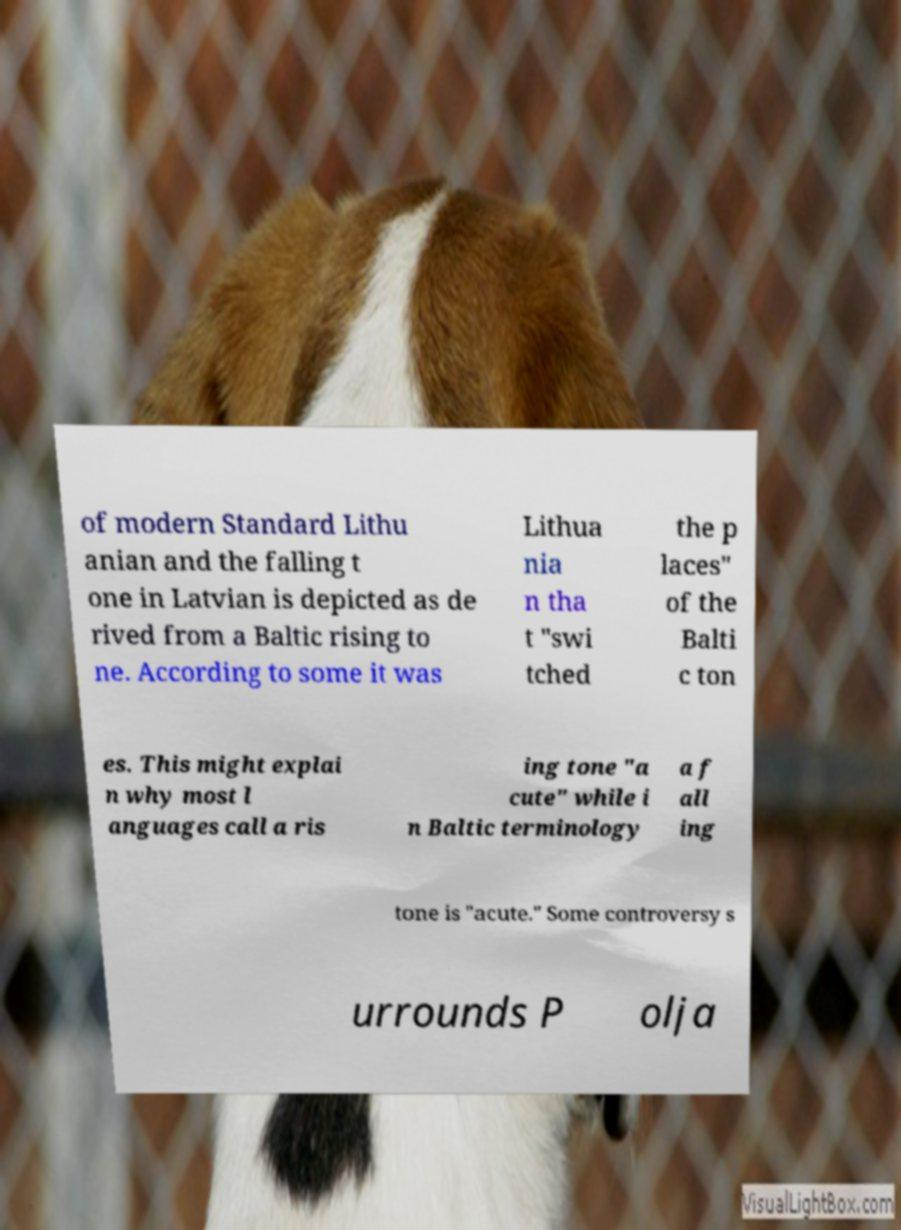For documentation purposes, I need the text within this image transcribed. Could you provide that? of modern Standard Lithu anian and the falling t one in Latvian is depicted as de rived from a Baltic rising to ne. According to some it was Lithua nia n tha t "swi tched the p laces" of the Balti c ton es. This might explai n why most l anguages call a ris ing tone "a cute" while i n Baltic terminology a f all ing tone is "acute." Some controversy s urrounds P olja 